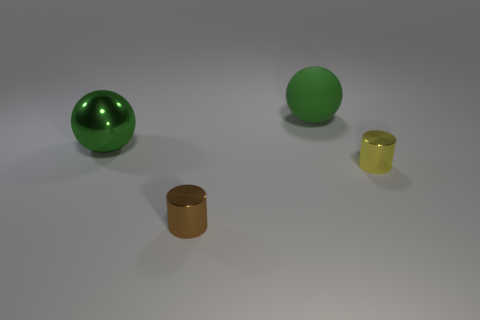Add 2 tiny gray spheres. How many objects exist? 6 Subtract all yellow cylinders. How many cylinders are left? 1 Subtract all cyan spheres. Subtract all brown cubes. How many spheres are left? 2 Subtract all small red rubber objects. Subtract all large metallic spheres. How many objects are left? 3 Add 2 big matte spheres. How many big matte spheres are left? 3 Add 4 big balls. How many big balls exist? 6 Subtract 0 blue cylinders. How many objects are left? 4 Subtract 2 balls. How many balls are left? 0 